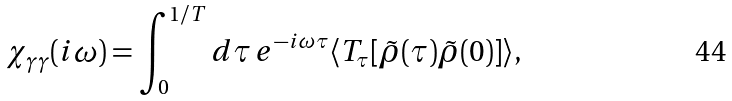<formula> <loc_0><loc_0><loc_500><loc_500>\chi _ { \gamma \gamma } ( i \omega ) = \int _ { 0 } ^ { 1 / T } d \tau \, e ^ { - i \omega \tau } \langle T _ { \tau } [ \tilde { \rho } ( \tau ) \tilde { \rho } ( 0 ) ] \rangle ,</formula> 